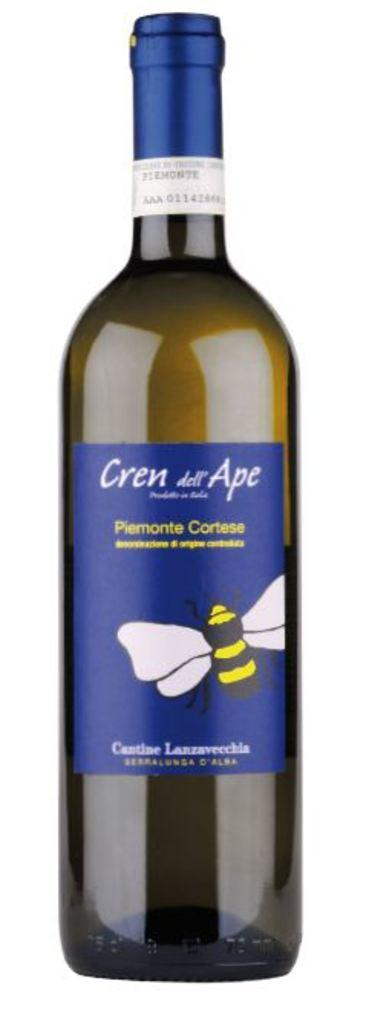What object can be seen in the image? There is a glass bottle in the image. How many bikes are being traded in the image? There are no bikes or trading activities present in the image; it features a glass bottle. 